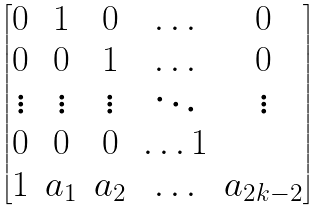<formula> <loc_0><loc_0><loc_500><loc_500>\begin{bmatrix} 0 & 1 & 0 & \hdots & 0 \\ 0 & 0 & 1 & \hdots & 0 \\ \vdots & \vdots & \vdots & \ddots & \vdots \\ 0 & 0 & 0 & \hdots 1 \\ 1 & a _ { 1 } & a _ { 2 } & \hdots & a _ { 2 k - 2 } \end{bmatrix}</formula> 